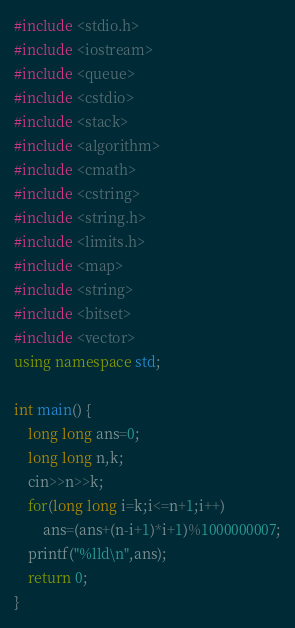<code> <loc_0><loc_0><loc_500><loc_500><_C++_>#include <stdio.h>
#include <iostream>
#include <queue>
#include <cstdio>
#include <stack>
#include <algorithm>
#include <cmath>
#include <cstring>
#include <string.h>
#include <limits.h>
#include <map>
#include <string>
#include <bitset>
#include <vector>
using namespace std;

int main() {
    long long ans=0;
    long long n,k;
    cin>>n>>k;
    for(long long i=k;i<=n+1;i++)
        ans=(ans+(n-i+1)*i+1)%1000000007;
    printf("%lld\n",ans);
    return 0;
}
</code> 